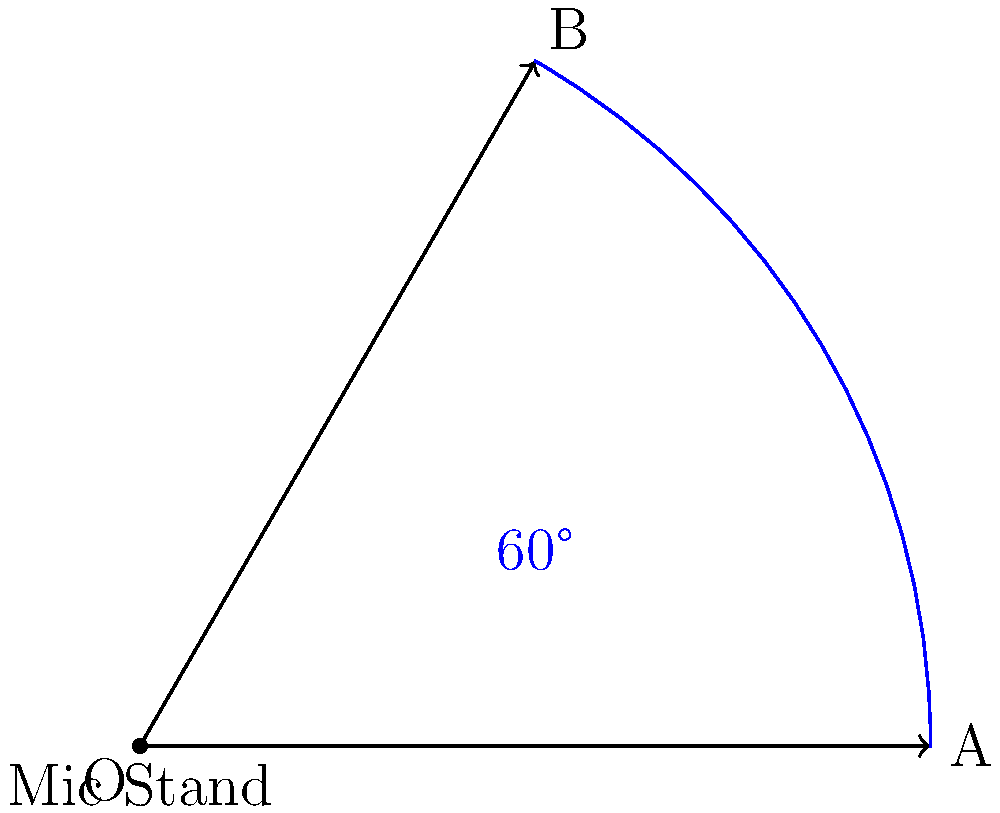At a Heltah Skeltah concert, the sound engineer needs to adjust a microphone stand. If the stand is initially positioned at point A and needs to be rotated 60° counterclockwise around point O to reach point B, what are the coordinates of point B? Assume OA = 2 units. To find the coordinates of point B after rotating point A by 60° counterclockwise around O, we can follow these steps:

1) Initially, point A is at (2,0) since OA = 2 units and it's on the x-axis.

2) To rotate a point (x,y) by an angle θ counterclockwise, we use the rotation matrix:
   $$ \begin{pmatrix} \cos θ & -\sin θ \\ \sin θ & \cos θ \end{pmatrix} $$

3) For 60°, we have:
   $$ \cos 60° = \frac{1}{2} \quad \text{and} \quad \sin 60° = \frac{\sqrt{3}}{2} $$

4) Applying the rotation to A(2,0):
   $$ \begin{pmatrix} \frac{1}{2} & -\frac{\sqrt{3}}{2} \\ \frac{\sqrt{3}}{2} & \frac{1}{2} \end{pmatrix} \begin{pmatrix} 2 \\ 0 \end{pmatrix} = \begin{pmatrix} 2 \cdot \frac{1}{2} + 0 \cdot (-\frac{\sqrt{3}}{2}) \\ 2 \cdot \frac{\sqrt{3}}{2} + 0 \cdot \frac{1}{2} \end{pmatrix} $$

5) Simplifying:
   $$ = \begin{pmatrix} 1 \\ \sqrt{3} \end{pmatrix} $$

Therefore, the coordinates of point B are $(1, \sqrt{3})$.
Answer: $(1, \sqrt{3})$ 